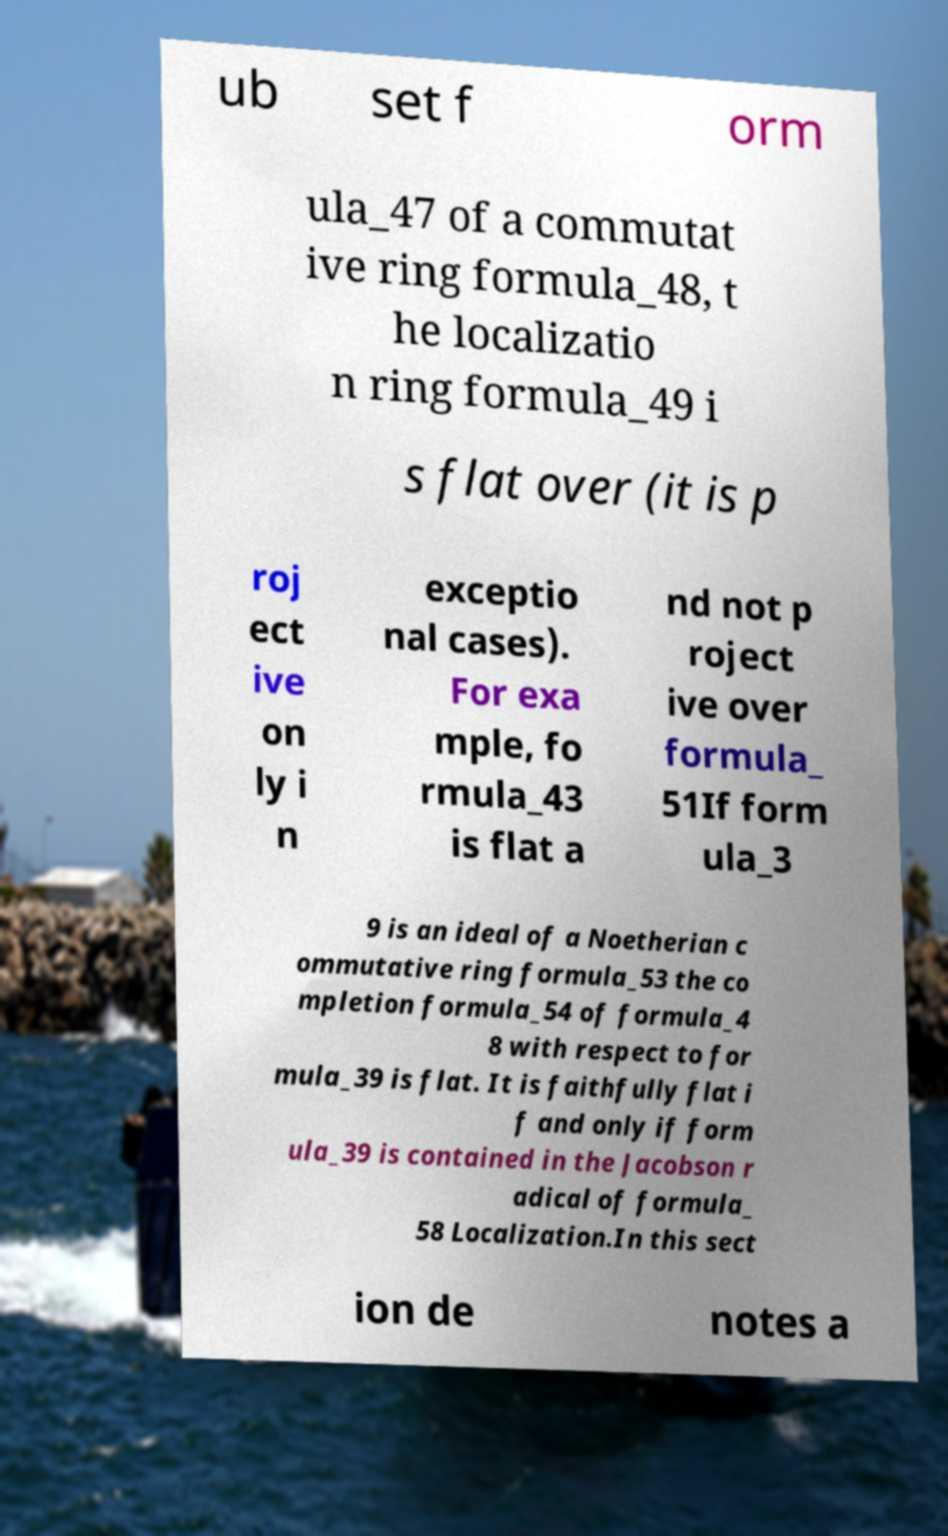I need the written content from this picture converted into text. Can you do that? ub set f orm ula_47 of a commutat ive ring formula_48, t he localizatio n ring formula_49 i s flat over (it is p roj ect ive on ly i n exceptio nal cases). For exa mple, fo rmula_43 is flat a nd not p roject ive over formula_ 51If form ula_3 9 is an ideal of a Noetherian c ommutative ring formula_53 the co mpletion formula_54 of formula_4 8 with respect to for mula_39 is flat. It is faithfully flat i f and only if form ula_39 is contained in the Jacobson r adical of formula_ 58 Localization.In this sect ion de notes a 